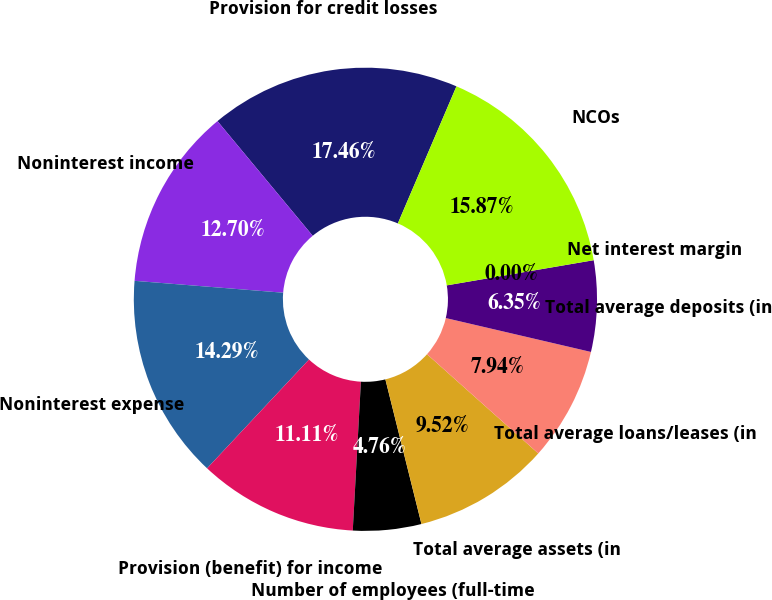<chart> <loc_0><loc_0><loc_500><loc_500><pie_chart><fcel>Provision for credit losses<fcel>Noninterest income<fcel>Noninterest expense<fcel>Provision (benefit) for income<fcel>Number of employees (full-time<fcel>Total average assets (in<fcel>Total average loans/leases (in<fcel>Total average deposits (in<fcel>Net interest margin<fcel>NCOs<nl><fcel>17.46%<fcel>12.7%<fcel>14.29%<fcel>11.11%<fcel>4.76%<fcel>9.52%<fcel>7.94%<fcel>6.35%<fcel>0.0%<fcel>15.87%<nl></chart> 